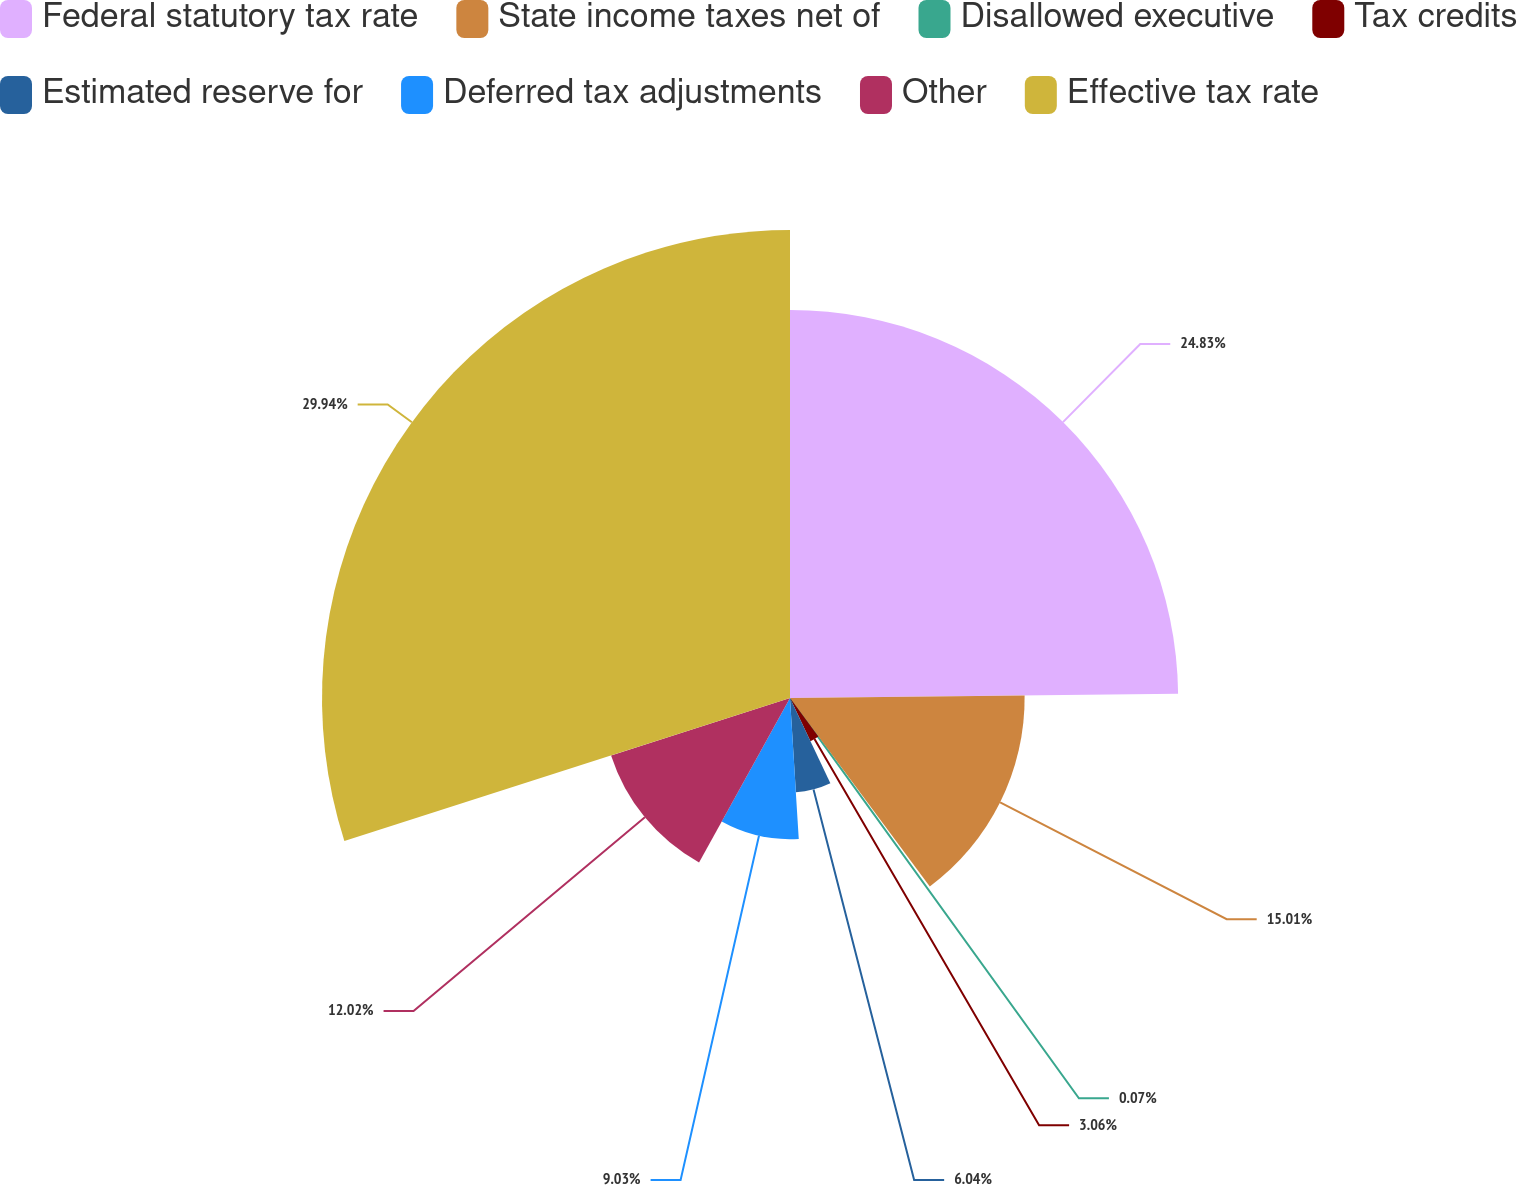Convert chart. <chart><loc_0><loc_0><loc_500><loc_500><pie_chart><fcel>Federal statutory tax rate<fcel>State income taxes net of<fcel>Disallowed executive<fcel>Tax credits<fcel>Estimated reserve for<fcel>Deferred tax adjustments<fcel>Other<fcel>Effective tax rate<nl><fcel>24.83%<fcel>15.01%<fcel>0.07%<fcel>3.06%<fcel>6.04%<fcel>9.03%<fcel>12.02%<fcel>29.94%<nl></chart> 